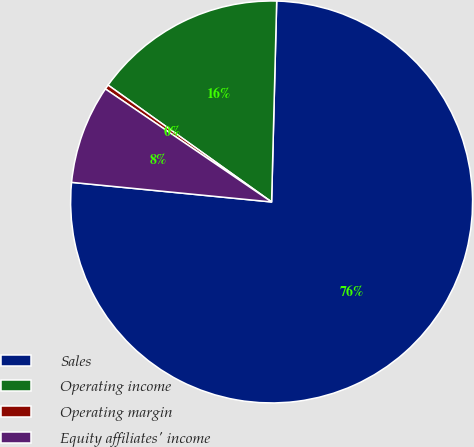Convert chart to OTSL. <chart><loc_0><loc_0><loc_500><loc_500><pie_chart><fcel>Sales<fcel>Operating income<fcel>Operating margin<fcel>Equity affiliates' income<nl><fcel>76.16%<fcel>15.53%<fcel>0.37%<fcel>7.95%<nl></chart> 